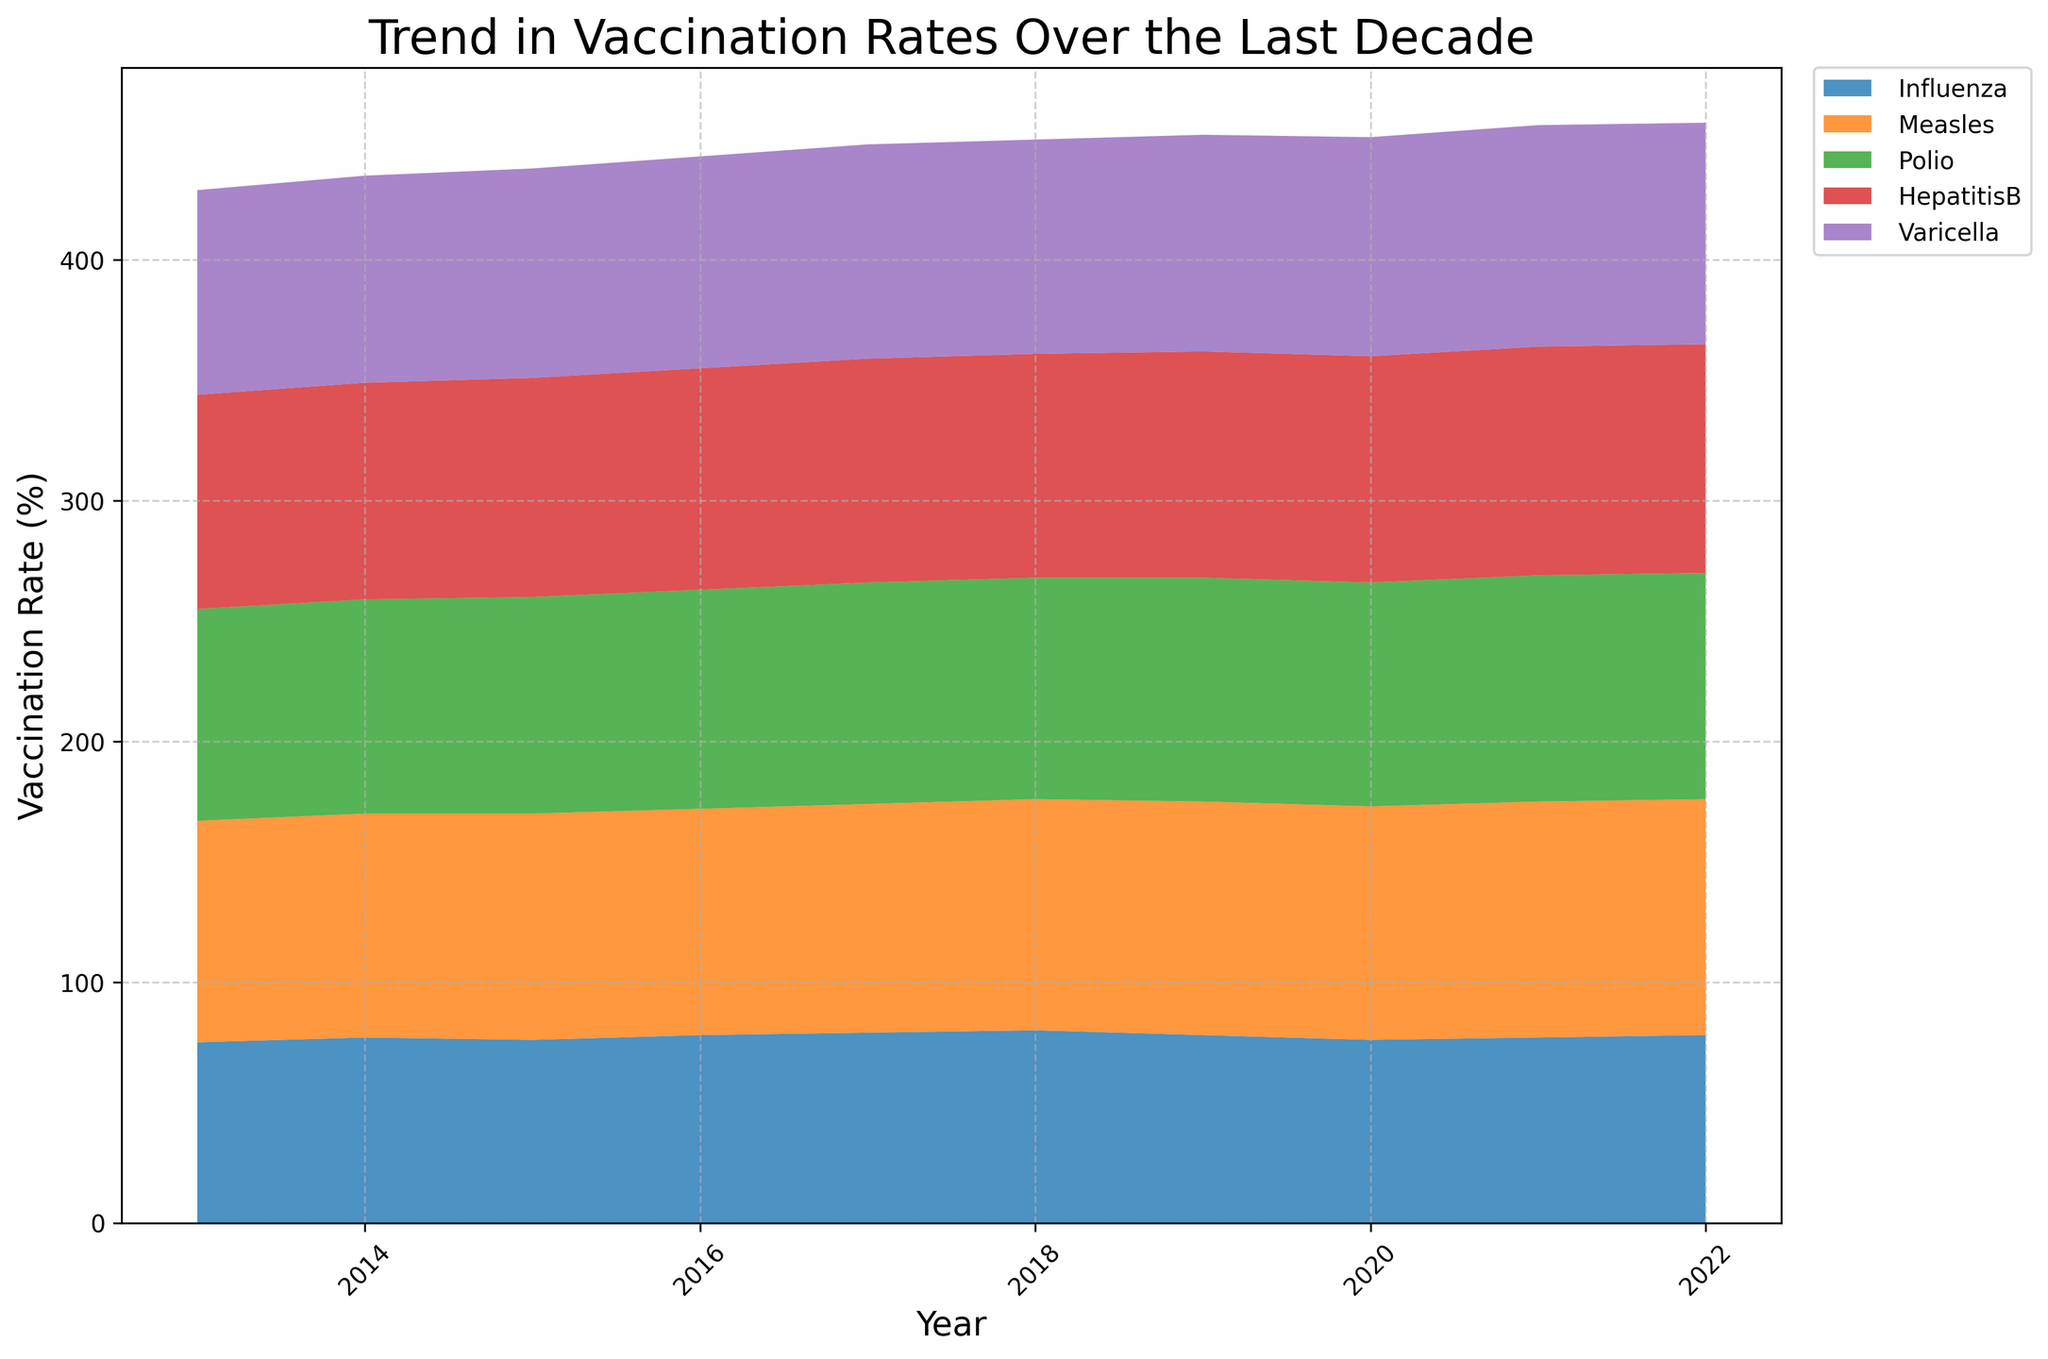What is the overall trend in vaccination rates for Influenza from 2013 to 2022? From the figure, the vaccination rate for Influenza starts at 75% in 2013, increases slightly to 80% by 2018, drops to 76% in 2020, and ends at 78% in 2022. The overall trend shows a slight fluctuation but general stability with a slight increase.
Answer: Slightly increasing with fluctuations Which vaccine shows the highest increase in vaccination rate over the last decade? By comparing the starting and ending rates for each vaccine from the area chart, Measles shows an increase from 92% in 2013 to 98% in 2022, which is the largest increase among all vaccines.
Answer: Measles What is the difference in the vaccination rates for Varicella between 2013 and 2022? The vaccination rate for Varicella is 85% in 2013 and 92% in 2022. The difference is 92% - 85% = 7%.
Answer: 7% How did the vaccination rate for HepatitisB compare from 2017 to 2020? In 2017, the rate is 93%, and it remains the same through 2020 at 94%. The vaccination rate for HepatitisB shows a slight increase and stabilization.
Answer: Slight increase and stable Which vaccine had the lowest vaccination rate in 2020, and what was the rate? By observing the stack plot for 2020, Influenza shows the lowest rate at 76%.
Answer: Influenza, 76% How does the vaccination rate for Polio in 2019 compare to 2015? From the chart, the vaccination rate for Polio is 90% in 2015 and 93% in 2019. The rate increased by 93% - 90% = 3%.
Answer: Increased by 3% Between which years did the vaccination rate for Measles remain constant? The chart shows that the vaccination rate for Measles remained at 94% from 2015 to 2016.
Answer: 2015 to 2016 What was the average vaccination rate for HepatitisB from 2013 to 2022? The rates for HepatitisB are 89, 90, 91, 92, 93, 93, 94, 94, 95, 95 respectively. Sum these values (89+90+91+92+93+93+94+94+95+95) = 926, then divide by 10 (number of years) to get 92.6%.
Answer: 92.6% Which vaccine had the most stable vaccination rate over the decade? By observing the consistency of the areas in the chart, HepatitisB shows the most stable rates with minimal fluctuations, ranging only from 89% to 95%.
Answer: HepatitisB 